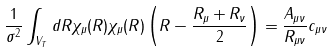<formula> <loc_0><loc_0><loc_500><loc_500>\frac { 1 } { \sigma ^ { 2 } } \int _ { V _ { T } } d { R } \chi _ { \mu } ( { R } ) \chi _ { \mu } ( { R } ) \left ( { R } - \frac { { R } _ { \mu } + { R } _ { \nu } } { 2 } \right ) = \frac { A _ { \mu \nu } } { R _ { \mu \nu } } { c } _ { \mu \nu }</formula> 